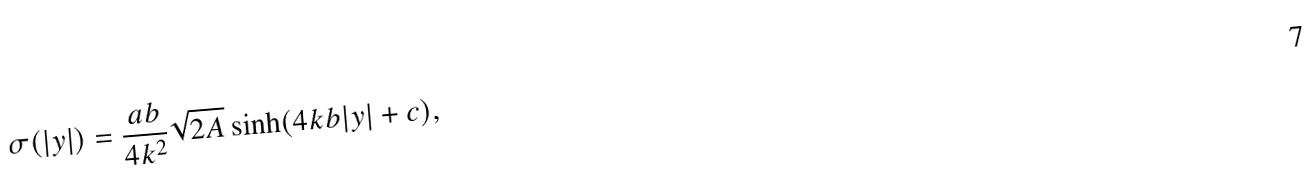Convert formula to latex. <formula><loc_0><loc_0><loc_500><loc_500>\sigma ( | y | ) = \frac { a b } { 4 k ^ { 2 } } \sqrt { 2 A } \sinh ( 4 k b | y | + c ) ,</formula> 